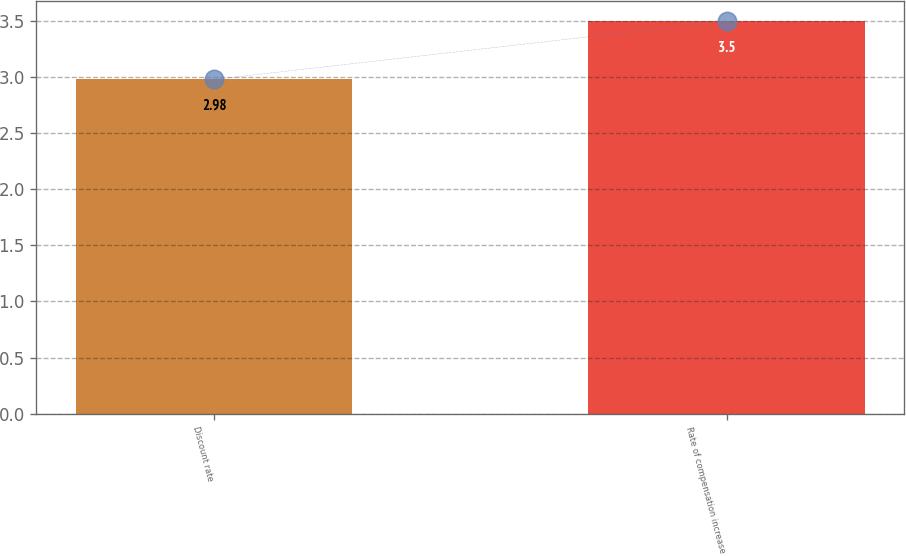<chart> <loc_0><loc_0><loc_500><loc_500><bar_chart><fcel>Discount rate<fcel>Rate of compensation increase<nl><fcel>2.98<fcel>3.5<nl></chart> 